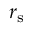Convert formula to latex. <formula><loc_0><loc_0><loc_500><loc_500>r _ { s }</formula> 